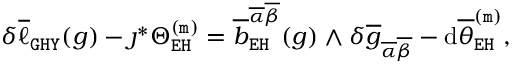Convert formula to latex. <formula><loc_0><loc_0><loc_500><loc_500>\begin{array} { r } { \delta \overline { \ell } _ { G H Y } ( g ) - \jmath ^ { * } \Theta _ { E H } ^ { ( m ) } = \overline { b } _ { E H } ^ { \overline { \alpha } \overline { \beta } } ( g ) \wedge \delta \overline { g } _ { \overline { \alpha } \overline { \beta } } - d \overline { \theta } _ { E H } ^ { ( m ) } , } \end{array}</formula> 